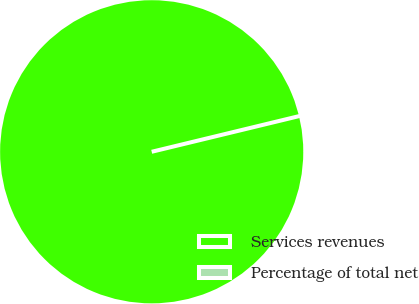Convert chart to OTSL. <chart><loc_0><loc_0><loc_500><loc_500><pie_chart><fcel>Services revenues<fcel>Percentage of total net<nl><fcel>100.0%<fcel>0.0%<nl></chart> 